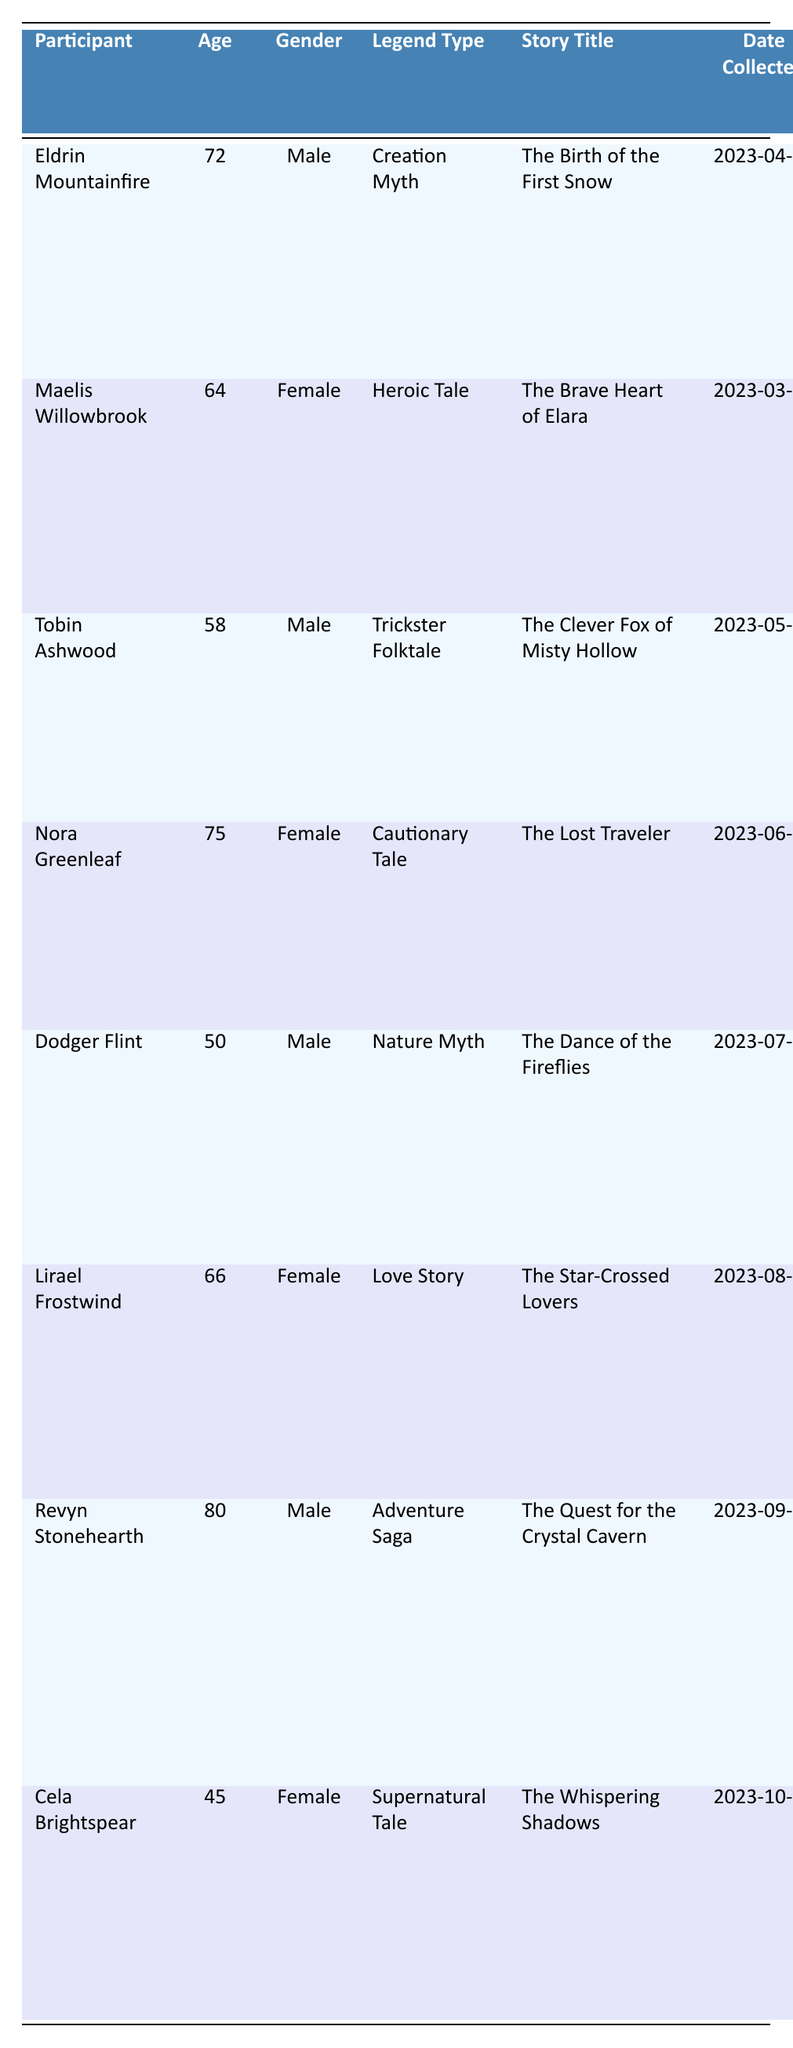What is the story title collected by Eldrin Mountainfire? The story title collected by Eldrin Mountainfire can be found in the "Story Title" column corresponding to his name in the "Participant" column, which is "The Birth of the First Snow."
Answer: The Birth of the First Snow How many female participants contributed stories? To find the number of female participants, we can count the entries under the "Gender" column that state "Female." There are four female participants: Maelis Willowbrook, Nora Greenleaf, Lirael Frostwind, and Cela Brightspear.
Answer: 4 What is the legend type associated with the story "The Clever Fox of Misty Hollow"? We can identify the legend type for the story "The Clever Fox of Misty Hollow" by locating it in the table and checking the corresponding "Legend Type," which is "Trickster Folktale."
Answer: Trickster Folktale Which participant collected their story using the method "Community Gathering"? The table shows that Maelis Willowbrook is the participant who used "Community Gathering" to collect her story, as indicated in her row.
Answer: Maelis Willowbrook What notable elements are associated with the story "The Lost Traveler"? Notable elements can be found in the "Notable Elements" column for the row corresponding to "The Lost Traveler," which includes "Mysterious fog, Echoing calls, Hidden ravine."
Answer: Mysterious fog, Echoing calls, Hidden ravine Who is the youngest participant, and what is their age? To determine the youngest participant, we can look for the minimum age in the "Age" column, which corresponds to Cela Brightspear at 45 years old.
Answer: Cela Brightspear, 45 How many participants shared their stories at a location with "Hollow" in its name? We can examine the "Location" column for entries containing "Hollow." The participants from "Misty Hollow," "Gloomy Hollow," and those having "Hollow" in their story location count up to three.
Answer: 3 Does Revyn Stonehearth have a story associated with an Adventure Saga? We check if Revyn Stonehearth's story matches the description of an "Adventure Saga." The table confirms that his story "The Quest for the Crystal Cavern" is indeed categorized under Adventure Saga, making the answer true.
Answer: Yes Which legend type was the most frequently reported in this documentation? We can tally the types in the "Legend Type" column: Creation Myth, Heroic Tale, Trickster Folktale, Cautionary Tale, Nature Myth, Love Story, Adventure Saga, and Supernatural Tale. Each type appears once, indicating no frequent category.
Answer: None, all unique What is the average age of all participants involved in storytelling? To find the average age, add all participants' ages: (72 + 64 + 58 + 75 + 50 + 66 + 80 + 45) = 510. There are eight participants, so the average age is 510/8 = 63.75.
Answer: 63.75 